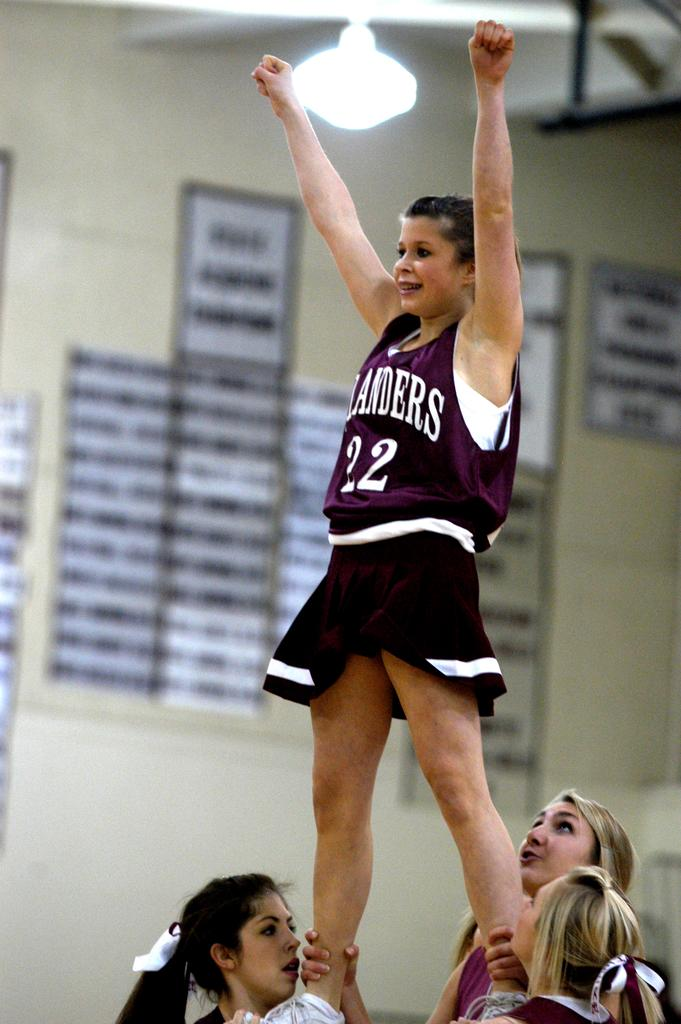<image>
Offer a succinct explanation of the picture presented. A cheerleader wearing the number 22 being held up by her teammates. 